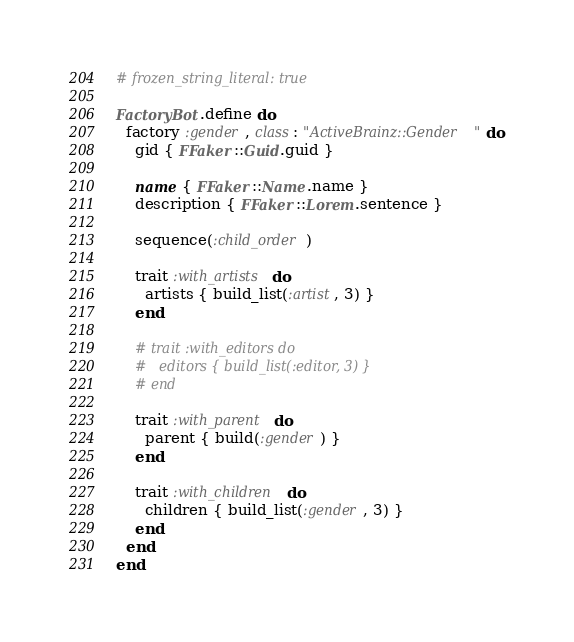Convert code to text. <code><loc_0><loc_0><loc_500><loc_500><_Ruby_># frozen_string_literal: true

FactoryBot.define do
  factory :gender, class: "ActiveBrainz::Gender" do
    gid { FFaker::Guid.guid }

    name { FFaker::Name.name }
    description { FFaker::Lorem.sentence }

    sequence(:child_order)

    trait :with_artists do
      artists { build_list(:artist, 3) }
    end

    # trait :with_editors do
    #   editors { build_list(:editor, 3) }
    # end

    trait :with_parent do
      parent { build(:gender) }
    end

    trait :with_children do
      children { build_list(:gender, 3) }
    end
  end
end
</code> 